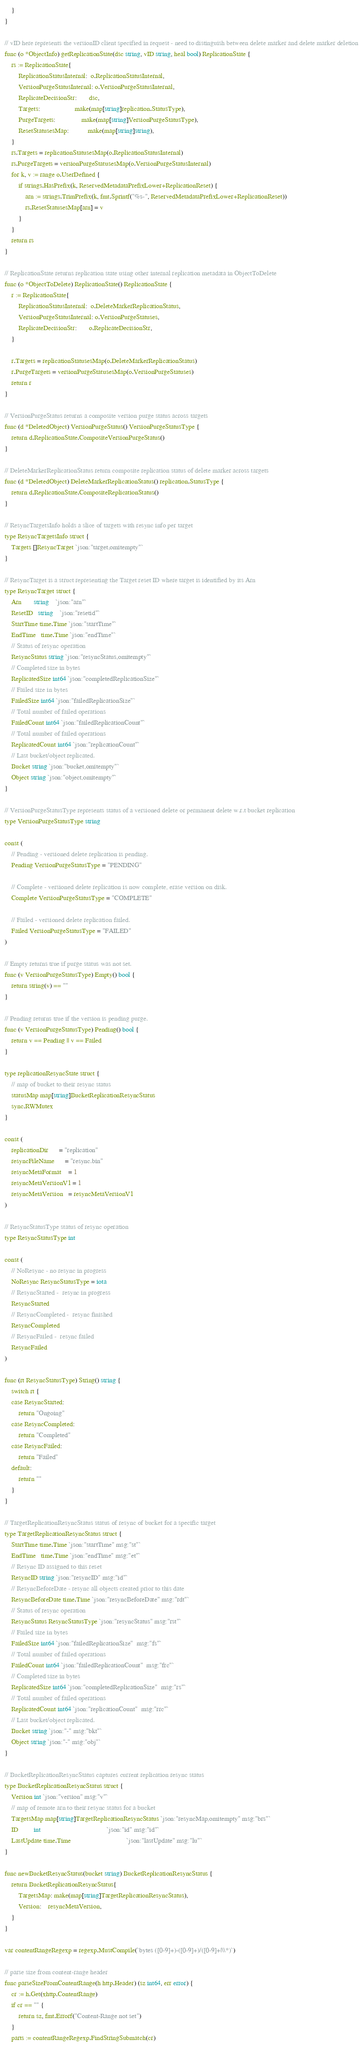<code> <loc_0><loc_0><loc_500><loc_500><_Go_>	}
}

// vID here represents the versionID client specified in request - need to distinguish between delete marker and delete marker deletion
func (o *ObjectInfo) getReplicationState(dsc string, vID string, heal bool) ReplicationState {
	rs := ReplicationState{
		ReplicationStatusInternal:  o.ReplicationStatusInternal,
		VersionPurgeStatusInternal: o.VersionPurgeStatusInternal,
		ReplicateDecisionStr:       dsc,
		Targets:                    make(map[string]replication.StatusType),
		PurgeTargets:               make(map[string]VersionPurgeStatusType),
		ResetStatusesMap:           make(map[string]string),
	}
	rs.Targets = replicationStatusesMap(o.ReplicationStatusInternal)
	rs.PurgeTargets = versionPurgeStatusesMap(o.VersionPurgeStatusInternal)
	for k, v := range o.UserDefined {
		if strings.HasPrefix(k, ReservedMetadataPrefixLower+ReplicationReset) {
			arn := strings.TrimPrefix(k, fmt.Sprintf("%s-", ReservedMetadataPrefixLower+ReplicationReset))
			rs.ResetStatusesMap[arn] = v
		}
	}
	return rs
}

// ReplicationState returns replication state using other internal replication metadata in ObjectToDelete
func (o *ObjectToDelete) ReplicationState() ReplicationState {
	r := ReplicationState{
		ReplicationStatusInternal:  o.DeleteMarkerReplicationStatus,
		VersionPurgeStatusInternal: o.VersionPurgeStatuses,
		ReplicateDecisionStr:       o.ReplicateDecisionStr,
	}

	r.Targets = replicationStatusesMap(o.DeleteMarkerReplicationStatus)
	r.PurgeTargets = versionPurgeStatusesMap(o.VersionPurgeStatuses)
	return r
}

// VersionPurgeStatus returns a composite version purge status across targets
func (d *DeletedObject) VersionPurgeStatus() VersionPurgeStatusType {
	return d.ReplicationState.CompositeVersionPurgeStatus()
}

// DeleteMarkerReplicationStatus return composite replication status of delete marker across targets
func (d *DeletedObject) DeleteMarkerReplicationStatus() replication.StatusType {
	return d.ReplicationState.CompositeReplicationStatus()
}

// ResyncTargetsInfo holds a slice of targets with resync info per target
type ResyncTargetsInfo struct {
	Targets []ResyncTarget `json:"target,omitempty"`
}

// ResyncTarget is a struct representing the Target reset ID where target is identified by its Arn
type ResyncTarget struct {
	Arn       string    `json:"arn"`
	ResetID   string    `json:"resetid"`
	StartTime time.Time `json:"startTime"`
	EndTime   time.Time `json:"endTime"`
	// Status of resync operation
	ResyncStatus string `json:"resyncStatus,omitempty"`
	// Completed size in bytes
	ReplicatedSize int64 `json:"completedReplicationSize"`
	// Failed size in bytes
	FailedSize int64 `json:"failedReplicationSize"`
	// Total number of failed operations
	FailedCount int64 `json:"failedReplicationCount"`
	// Total number of failed operations
	ReplicatedCount int64 `json:"replicationCount"`
	// Last bucket/object replicated.
	Bucket string `json:"bucket,omitempty"`
	Object string `json:"object,omitempty"`
}

// VersionPurgeStatusType represents status of a versioned delete or permanent delete w.r.t bucket replication
type VersionPurgeStatusType string

const (
	// Pending - versioned delete replication is pending.
	Pending VersionPurgeStatusType = "PENDING"

	// Complete - versioned delete replication is now complete, erase version on disk.
	Complete VersionPurgeStatusType = "COMPLETE"

	// Failed - versioned delete replication failed.
	Failed VersionPurgeStatusType = "FAILED"
)

// Empty returns true if purge status was not set.
func (v VersionPurgeStatusType) Empty() bool {
	return string(v) == ""
}

// Pending returns true if the version is pending purge.
func (v VersionPurgeStatusType) Pending() bool {
	return v == Pending || v == Failed
}

type replicationResyncState struct {
	// map of bucket to their resync status
	statusMap map[string]BucketReplicationResyncStatus
	sync.RWMutex
}

const (
	replicationDir      = "replication"
	resyncFileName      = "resync.bin"
	resyncMetaFormat    = 1
	resyncMetaVersionV1 = 1
	resyncMetaVersion   = resyncMetaVersionV1
)

// ResyncStatusType status of resync operation
type ResyncStatusType int

const (
	// NoResync - no resync in progress
	NoResync ResyncStatusType = iota
	// ResyncStarted -  resync in progress
	ResyncStarted
	// ResyncCompleted -  resync finished
	ResyncCompleted
	// ResyncFailed -  resync failed
	ResyncFailed
)

func (rt ResyncStatusType) String() string {
	switch rt {
	case ResyncStarted:
		return "Ongoing"
	case ResyncCompleted:
		return "Completed"
	case ResyncFailed:
		return "Failed"
	default:
		return ""
	}
}

// TargetReplicationResyncStatus status of resync of bucket for a specific target
type TargetReplicationResyncStatus struct {
	StartTime time.Time `json:"startTime" msg:"st"`
	EndTime   time.Time `json:"endTime" msg:"et"`
	// Resync ID assigned to this reset
	ResyncID string `json:"resyncID" msg:"id"`
	// ResyncBeforeDate - resync all objects created prior to this date
	ResyncBeforeDate time.Time `json:"resyncBeforeDate" msg:"rdt"`
	// Status of resync operation
	ResyncStatus ResyncStatusType `json:"resyncStatus" msg:"rst"`
	// Failed size in bytes
	FailedSize int64 `json:"failedReplicationSize"  msg:"fs"`
	// Total number of failed operations
	FailedCount int64 `json:"failedReplicationCount"  msg:"frc"`
	// Completed size in bytes
	ReplicatedSize int64 `json:"completedReplicationSize"  msg:"rs"`
	// Total number of failed operations
	ReplicatedCount int64 `json:"replicationCount"  msg:"rrc"`
	// Last bucket/object replicated.
	Bucket string `json:"-" msg:"bkt"`
	Object string `json:"-" msg:"obj"`
}

// BucketReplicationResyncStatus captures current replication resync status
type BucketReplicationResyncStatus struct {
	Version int `json:"version" msg:"v"`
	// map of remote arn to their resync status for a bucket
	TargetsMap map[string]TargetReplicationResyncStatus `json:"resyncMap,omitempty" msg:"brs"`
	ID         int                                      `json:"id" msg:"id"`
	LastUpdate time.Time                                `json:"lastUpdate" msg:"lu"`
}

func newBucketResyncStatus(bucket string) BucketReplicationResyncStatus {
	return BucketReplicationResyncStatus{
		TargetsMap: make(map[string]TargetReplicationResyncStatus),
		Version:    resyncMetaVersion,
	}
}

var contentRangeRegexp = regexp.MustCompile(`bytes ([0-9]+)-([0-9]+)/([0-9]+|\\*)`)

// parse size from content-range header
func parseSizeFromContentRange(h http.Header) (sz int64, err error) {
	cr := h.Get(xhttp.ContentRange)
	if cr == "" {
		return sz, fmt.Errorf("Content-Range not set")
	}
	parts := contentRangeRegexp.FindStringSubmatch(cr)</code> 